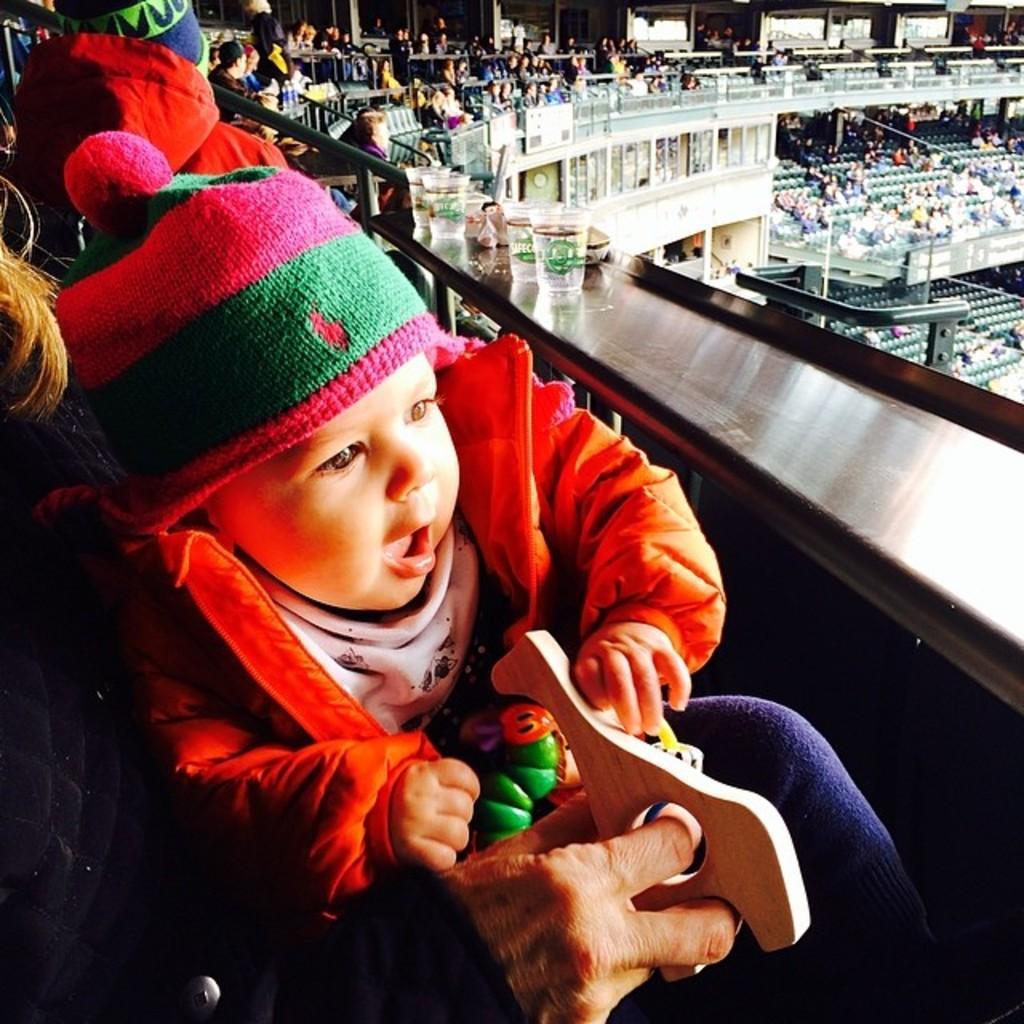Can you describe this image briefly? In this image I can see the stadium and I see number of people who are sitting and I see the glasses on this silver color thing and I see this baby is wearing a cap. 